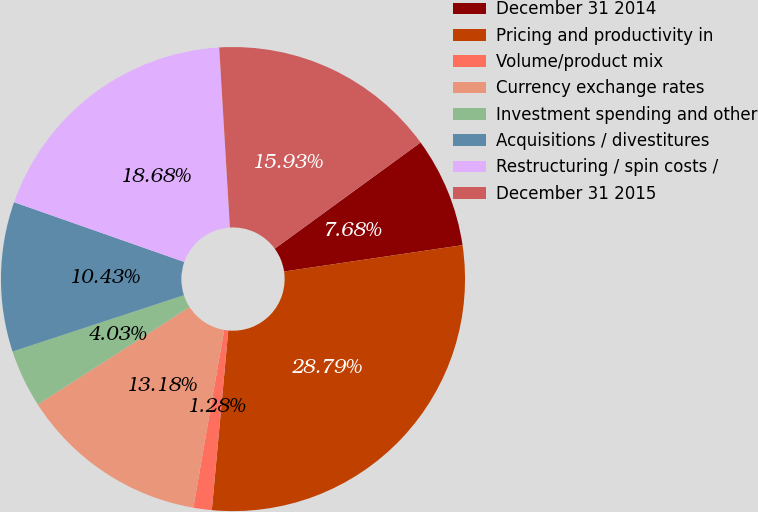Convert chart. <chart><loc_0><loc_0><loc_500><loc_500><pie_chart><fcel>December 31 2014<fcel>Pricing and productivity in<fcel>Volume/product mix<fcel>Currency exchange rates<fcel>Investment spending and other<fcel>Acquisitions / divestitures<fcel>Restructuring / spin costs /<fcel>December 31 2015<nl><fcel>7.68%<fcel>28.79%<fcel>1.28%<fcel>13.18%<fcel>4.03%<fcel>10.43%<fcel>18.68%<fcel>15.93%<nl></chart> 